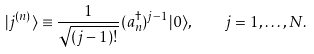Convert formula to latex. <formula><loc_0><loc_0><loc_500><loc_500>| j ^ { ( n ) } \rangle \equiv \frac { 1 } { \sqrt { ( j - 1 ) ! } } ( a _ { n } ^ { \dagger } ) ^ { j - 1 } | 0 \rangle , \quad j = 1 , \dots , N .</formula> 